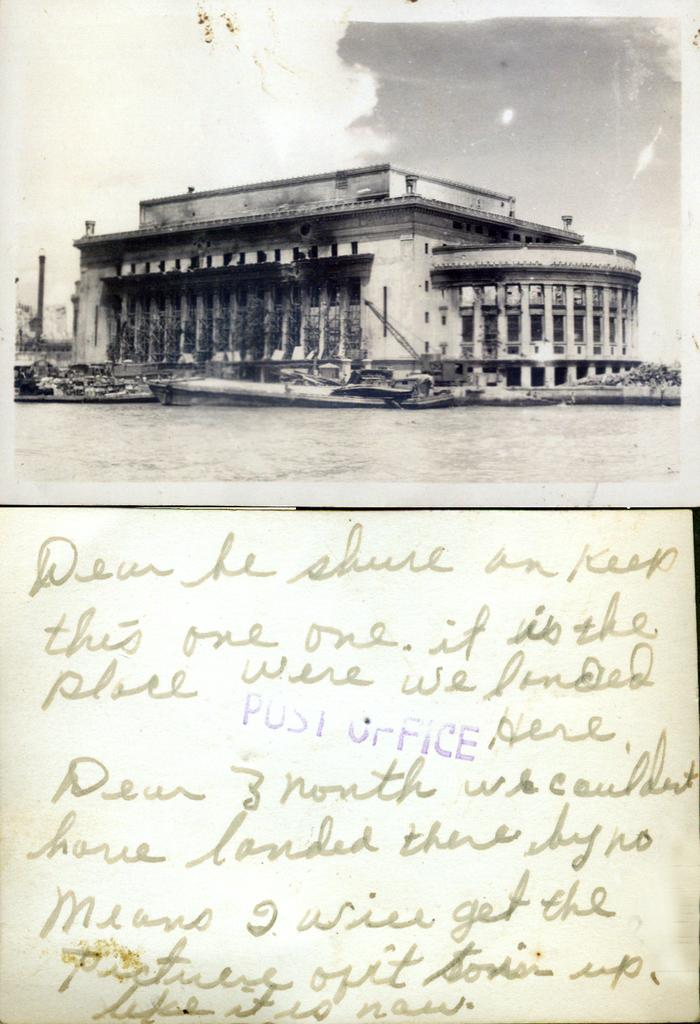<image>
Offer a succinct explanation of the picture presented. A personal handwritten note indicating the significance of an older stone building. 